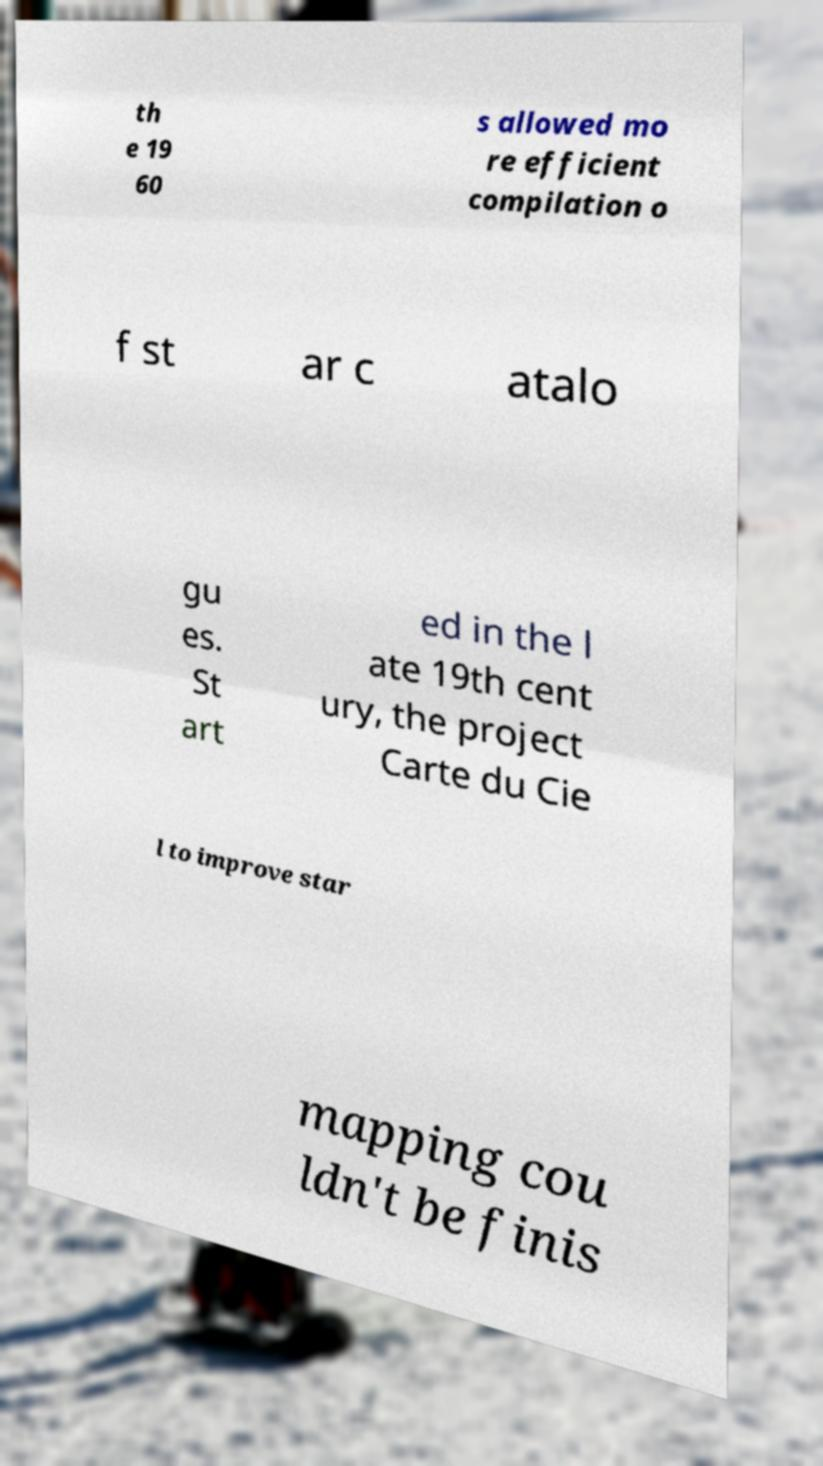What messages or text are displayed in this image? I need them in a readable, typed format. th e 19 60 s allowed mo re efficient compilation o f st ar c atalo gu es. St art ed in the l ate 19th cent ury, the project Carte du Cie l to improve star mapping cou ldn't be finis 